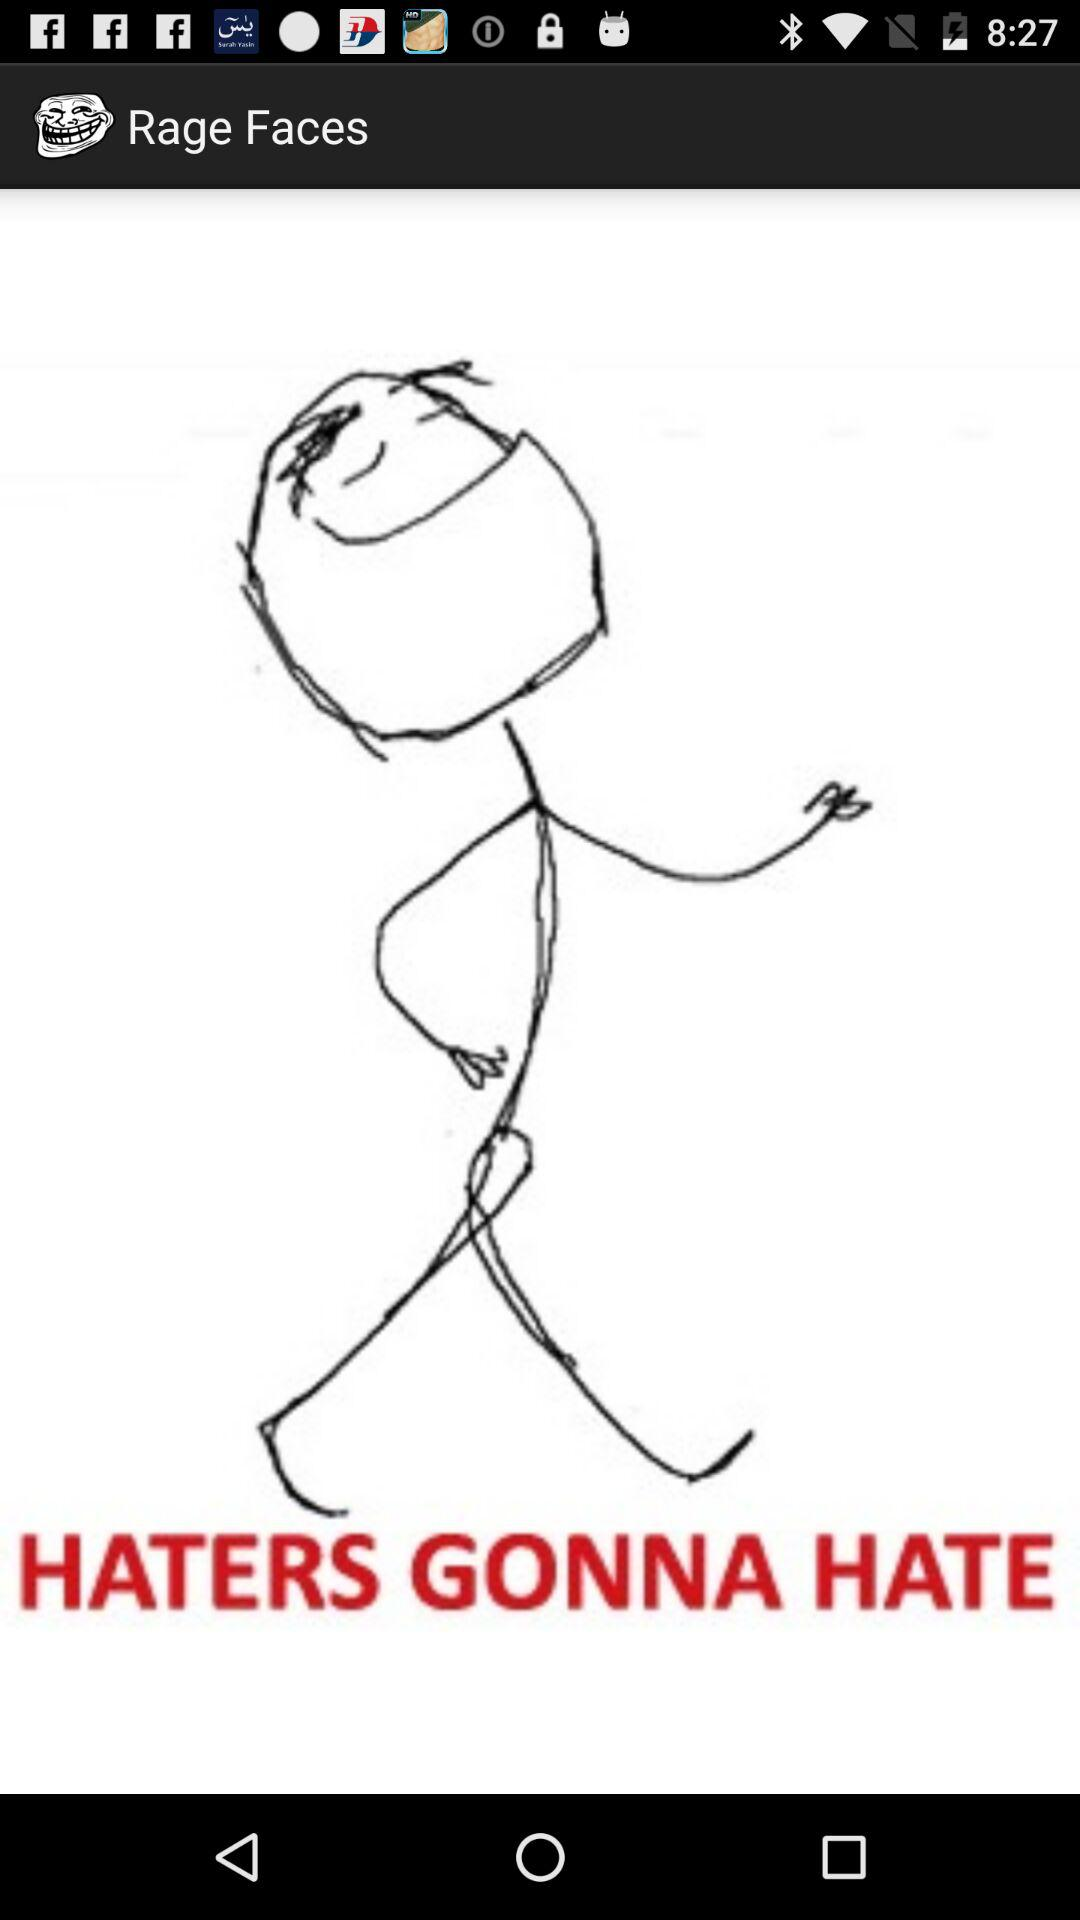What is the name of the application? The name of the application is "Rage Faces". 